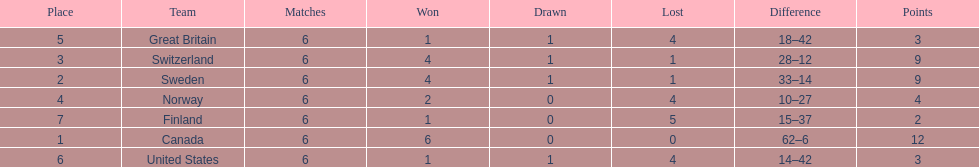Which country finished below the united states? Finland. 